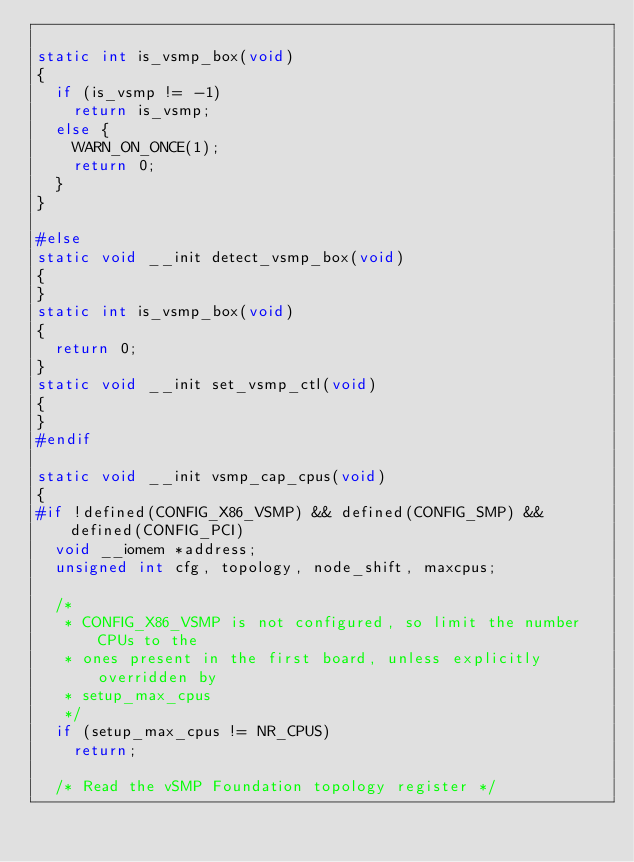<code> <loc_0><loc_0><loc_500><loc_500><_C_>
static int is_vsmp_box(void)
{
	if (is_vsmp != -1)
		return is_vsmp;
	else {
		WARN_ON_ONCE(1);
		return 0;
	}
}

#else
static void __init detect_vsmp_box(void)
{
}
static int is_vsmp_box(void)
{
	return 0;
}
static void __init set_vsmp_ctl(void)
{
}
#endif

static void __init vsmp_cap_cpus(void)
{
#if !defined(CONFIG_X86_VSMP) && defined(CONFIG_SMP) && defined(CONFIG_PCI)
	void __iomem *address;
	unsigned int cfg, topology, node_shift, maxcpus;

	/*
	 * CONFIG_X86_VSMP is not configured, so limit the number CPUs to the
	 * ones present in the first board, unless explicitly overridden by
	 * setup_max_cpus
	 */
	if (setup_max_cpus != NR_CPUS)
		return;

	/* Read the vSMP Foundation topology register */</code> 